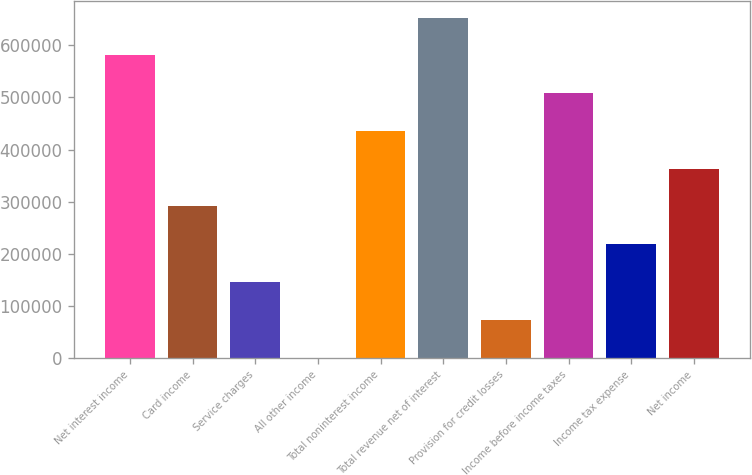Convert chart to OTSL. <chart><loc_0><loc_0><loc_500><loc_500><bar_chart><fcel>Net interest income<fcel>Card income<fcel>Service charges<fcel>All other income<fcel>Total noninterest income<fcel>Total revenue net of interest<fcel>Provision for credit losses<fcel>Income before income taxes<fcel>Income tax expense<fcel>Net income<nl><fcel>580500<fcel>290689<fcel>145784<fcel>878<fcel>435595<fcel>652953<fcel>73330.8<fcel>508048<fcel>218236<fcel>363142<nl></chart> 